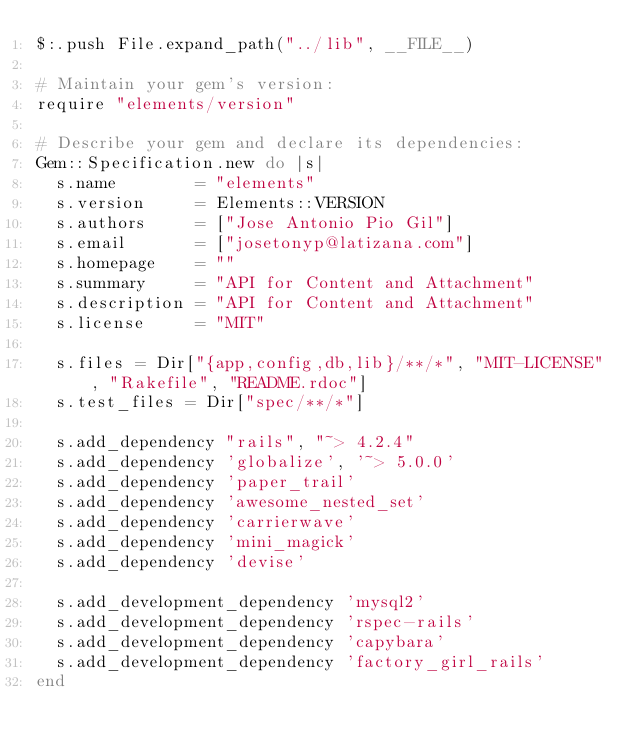Convert code to text. <code><loc_0><loc_0><loc_500><loc_500><_Ruby_>$:.push File.expand_path("../lib", __FILE__)

# Maintain your gem's version:
require "elements/version"

# Describe your gem and declare its dependencies:
Gem::Specification.new do |s|
  s.name        = "elements"
  s.version     = Elements::VERSION
  s.authors     = ["Jose Antonio Pio Gil"]
  s.email       = ["josetonyp@latizana.com"]
  s.homepage    = ""
  s.summary     = "API for Content and Attachment"
  s.description = "API for Content and Attachment"
  s.license     = "MIT"

  s.files = Dir["{app,config,db,lib}/**/*", "MIT-LICENSE", "Rakefile", "README.rdoc"]
  s.test_files = Dir["spec/**/*"]

  s.add_dependency "rails", "~> 4.2.4"
  s.add_dependency 'globalize', '~> 5.0.0'
  s.add_dependency 'paper_trail'
  s.add_dependency 'awesome_nested_set'
  s.add_dependency 'carrierwave'
  s.add_dependency 'mini_magick'
  s.add_dependency 'devise'

  s.add_development_dependency 'mysql2'
  s.add_development_dependency 'rspec-rails'
  s.add_development_dependency 'capybara'
  s.add_development_dependency 'factory_girl_rails'
end
</code> 